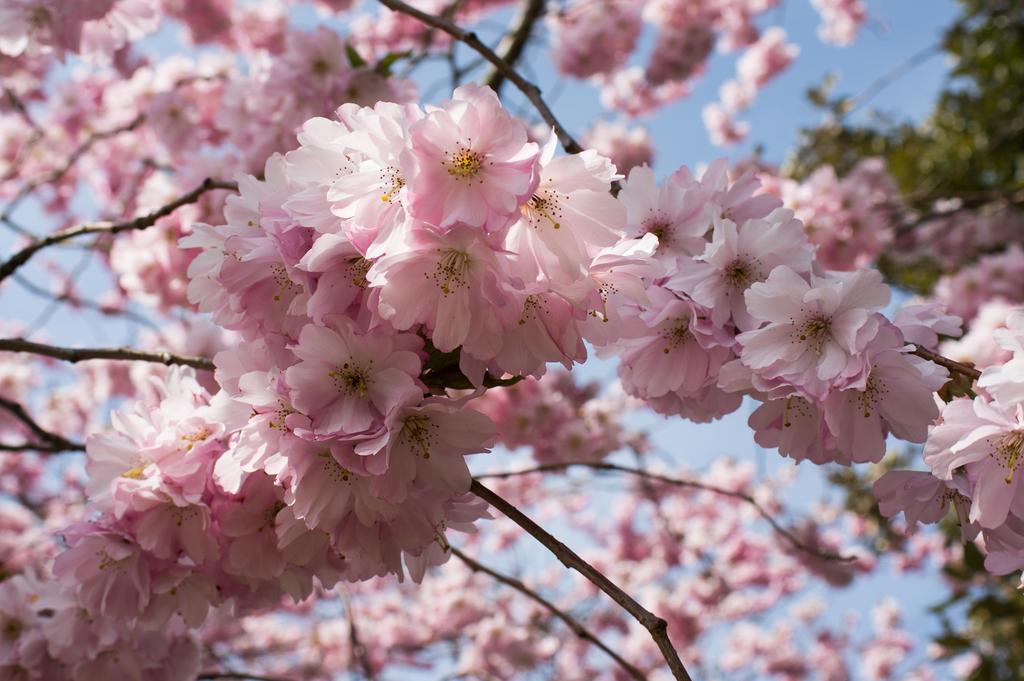In one or two sentences, can you explain what this image depicts? This image is taken outdoors. In the background there is a sky. In this image there is a tree with many flowers. Those flowers are pink in color. 